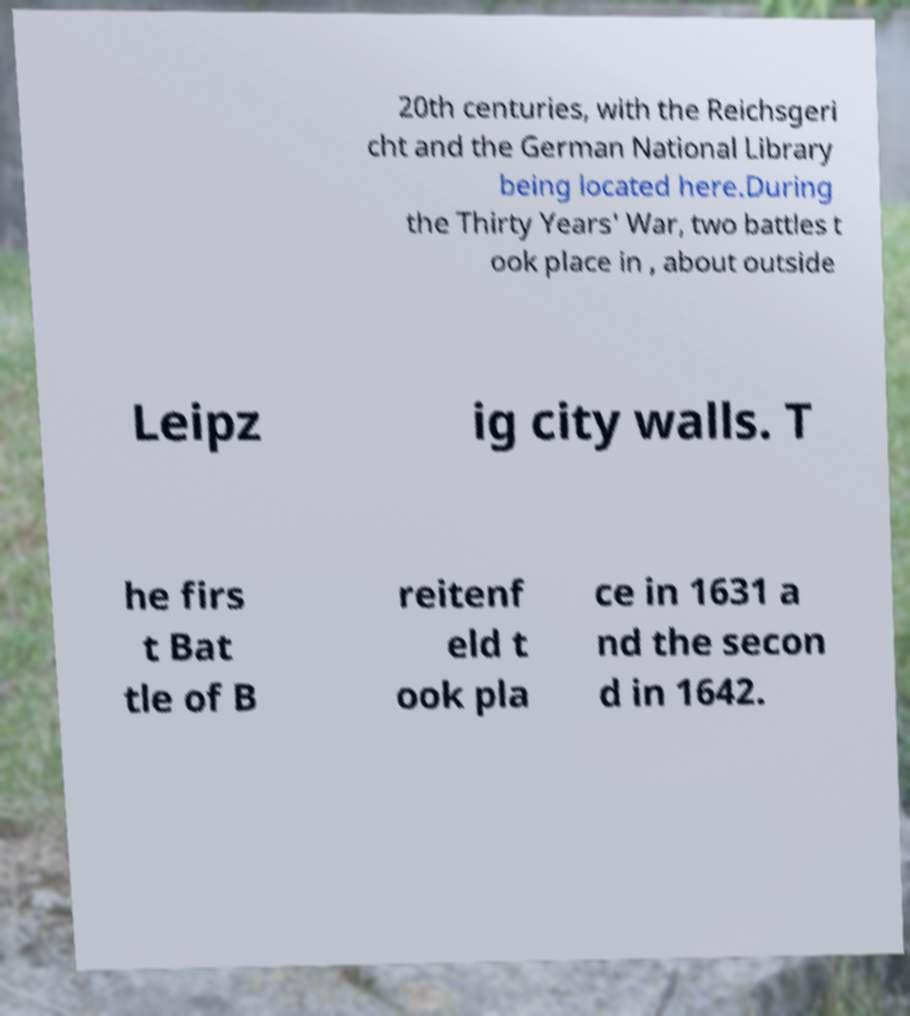Can you accurately transcribe the text from the provided image for me? 20th centuries, with the Reichsgeri cht and the German National Library being located here.During the Thirty Years' War, two battles t ook place in , about outside Leipz ig city walls. T he firs t Bat tle of B reitenf eld t ook pla ce in 1631 a nd the secon d in 1642. 